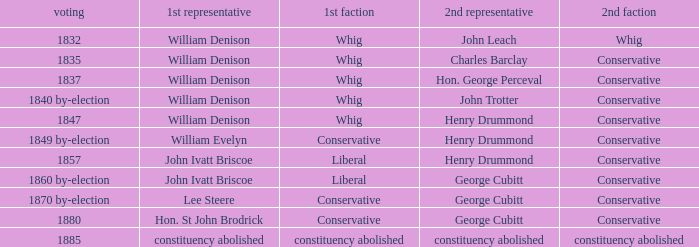Which party with an 1835 election has 1st member William Denison? Conservative. 